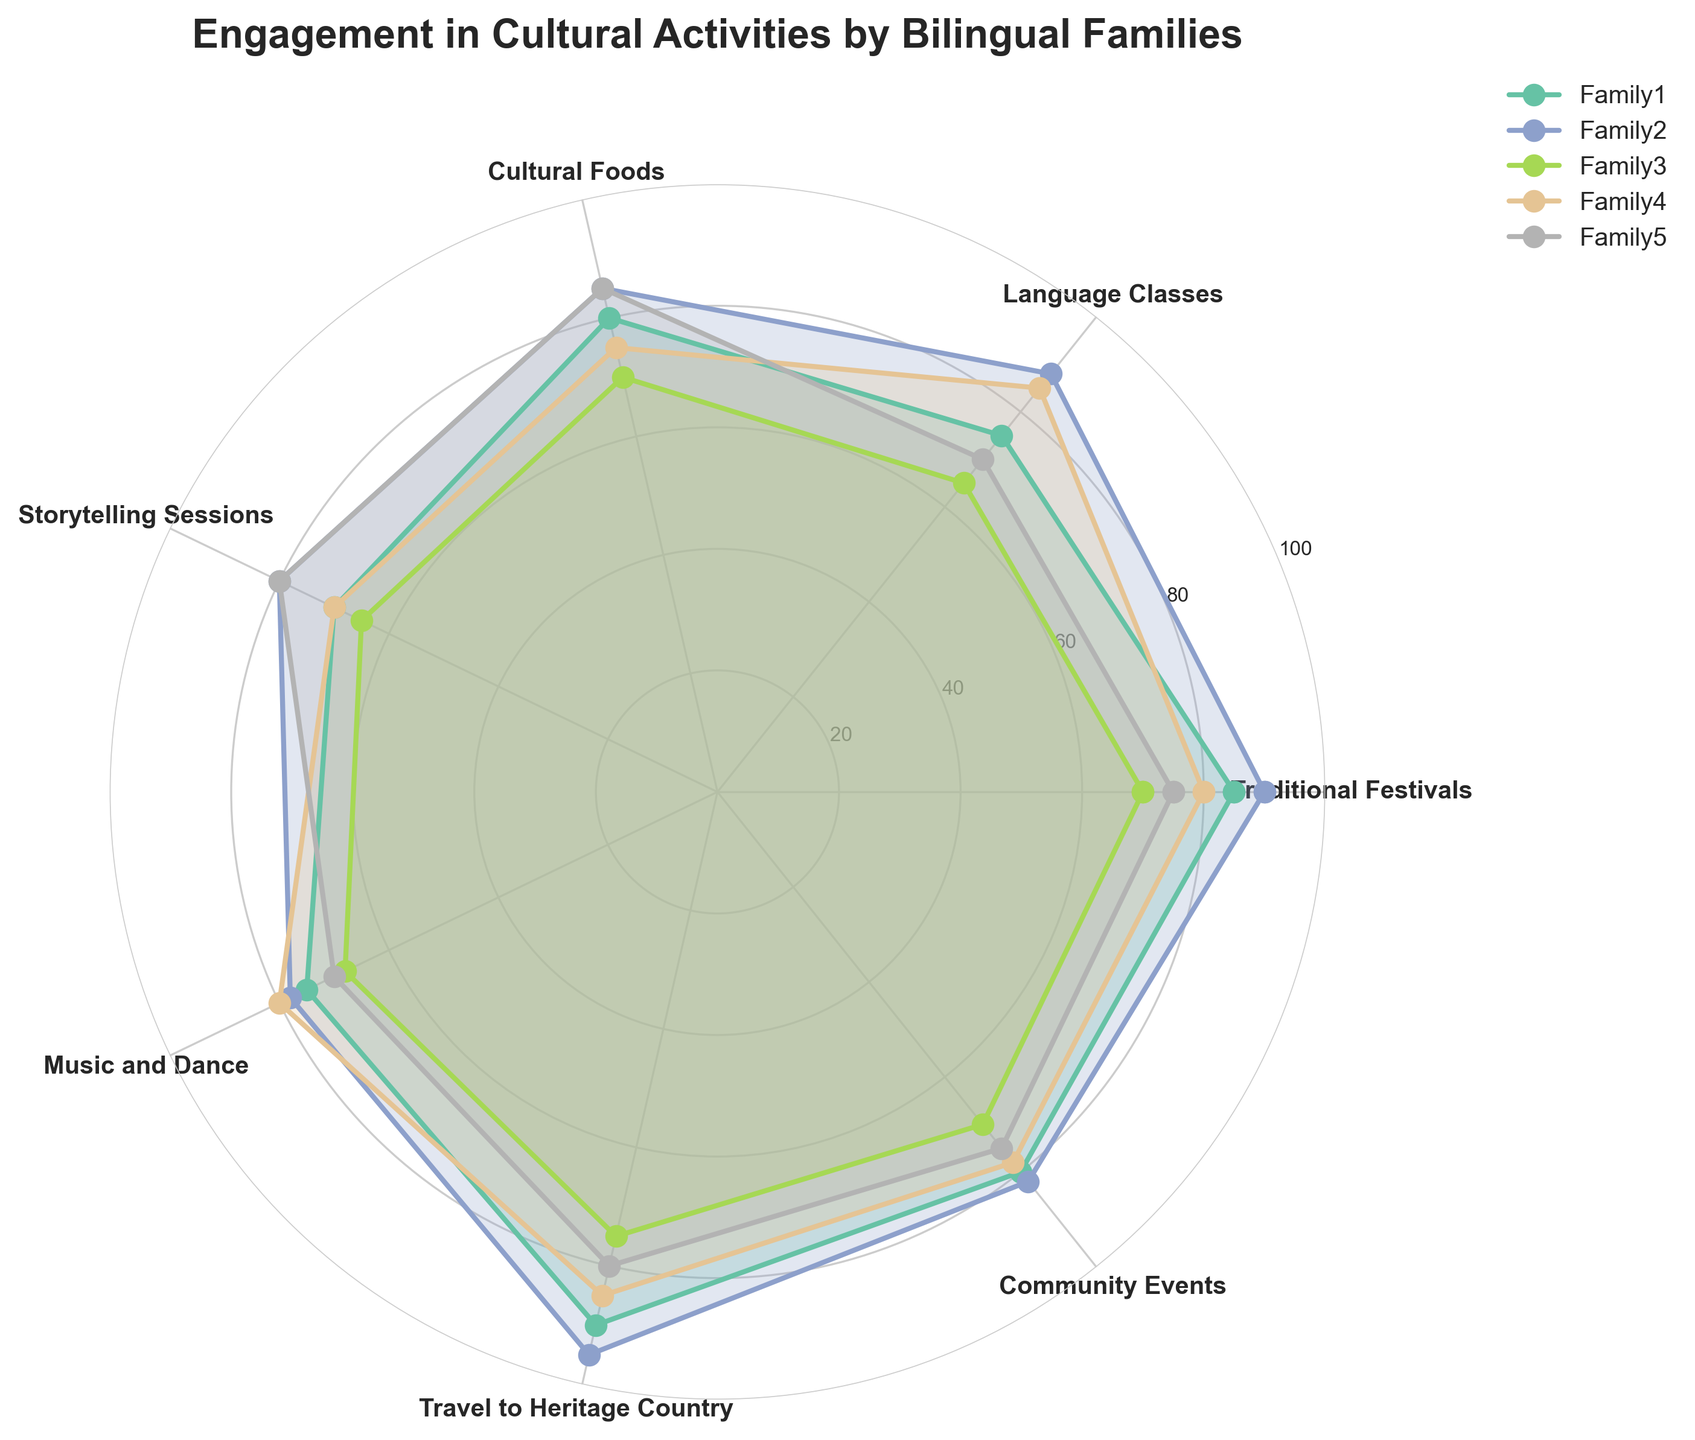What is the title of the radar chart? The title of the chart is displayed at the top of the figure. The title reads "Engagement in Cultural Activities by Bilingual Families".
Answer: Engagement in Cultural Activities by Bilingual Families Which family participates the most in Language Classes? By looking at the plot for Language Classes, the family with the highest data point will be the most participative. Family2 has the highest engagement, marked at 88.
Answer: Family2 Which activity shows the maximum engagement overall? By examining each activity across all families, the highest value is at Travel to Heritage Country with Family2 scoring 95.
Answer: Travel to Heritage Country What is the average engagement level for Cultural Foods across all families? Sum all the engagement levels for Cultural Foods (80 + 85 + 70 + 75 + 85) = 395, then divide by the number of families (5). The average engagement level is 395/5 = 79.
Answer: 79 How does Family4's participation in Traditional Festivals compare to its participation in Music and Dance? Check Family4's points on Traditional Festivals (80) and Music and Dance (80). Both values are the same, indicating equal participation.
Answer: Equal What is the lowest engagement level for any activity among all families? The lowest engagement level identified across all families and activities is 65, which appears in Language Classes and Storytelling Sessions for Family3.
Answer: 65 Which family has the most consistent engagement across all activities? For each family, observe the plot lines; the family with the least variance in the distances from the center will show consistency. Family2 generally maintains high and consistent engagement levels.
Answer: Family2 